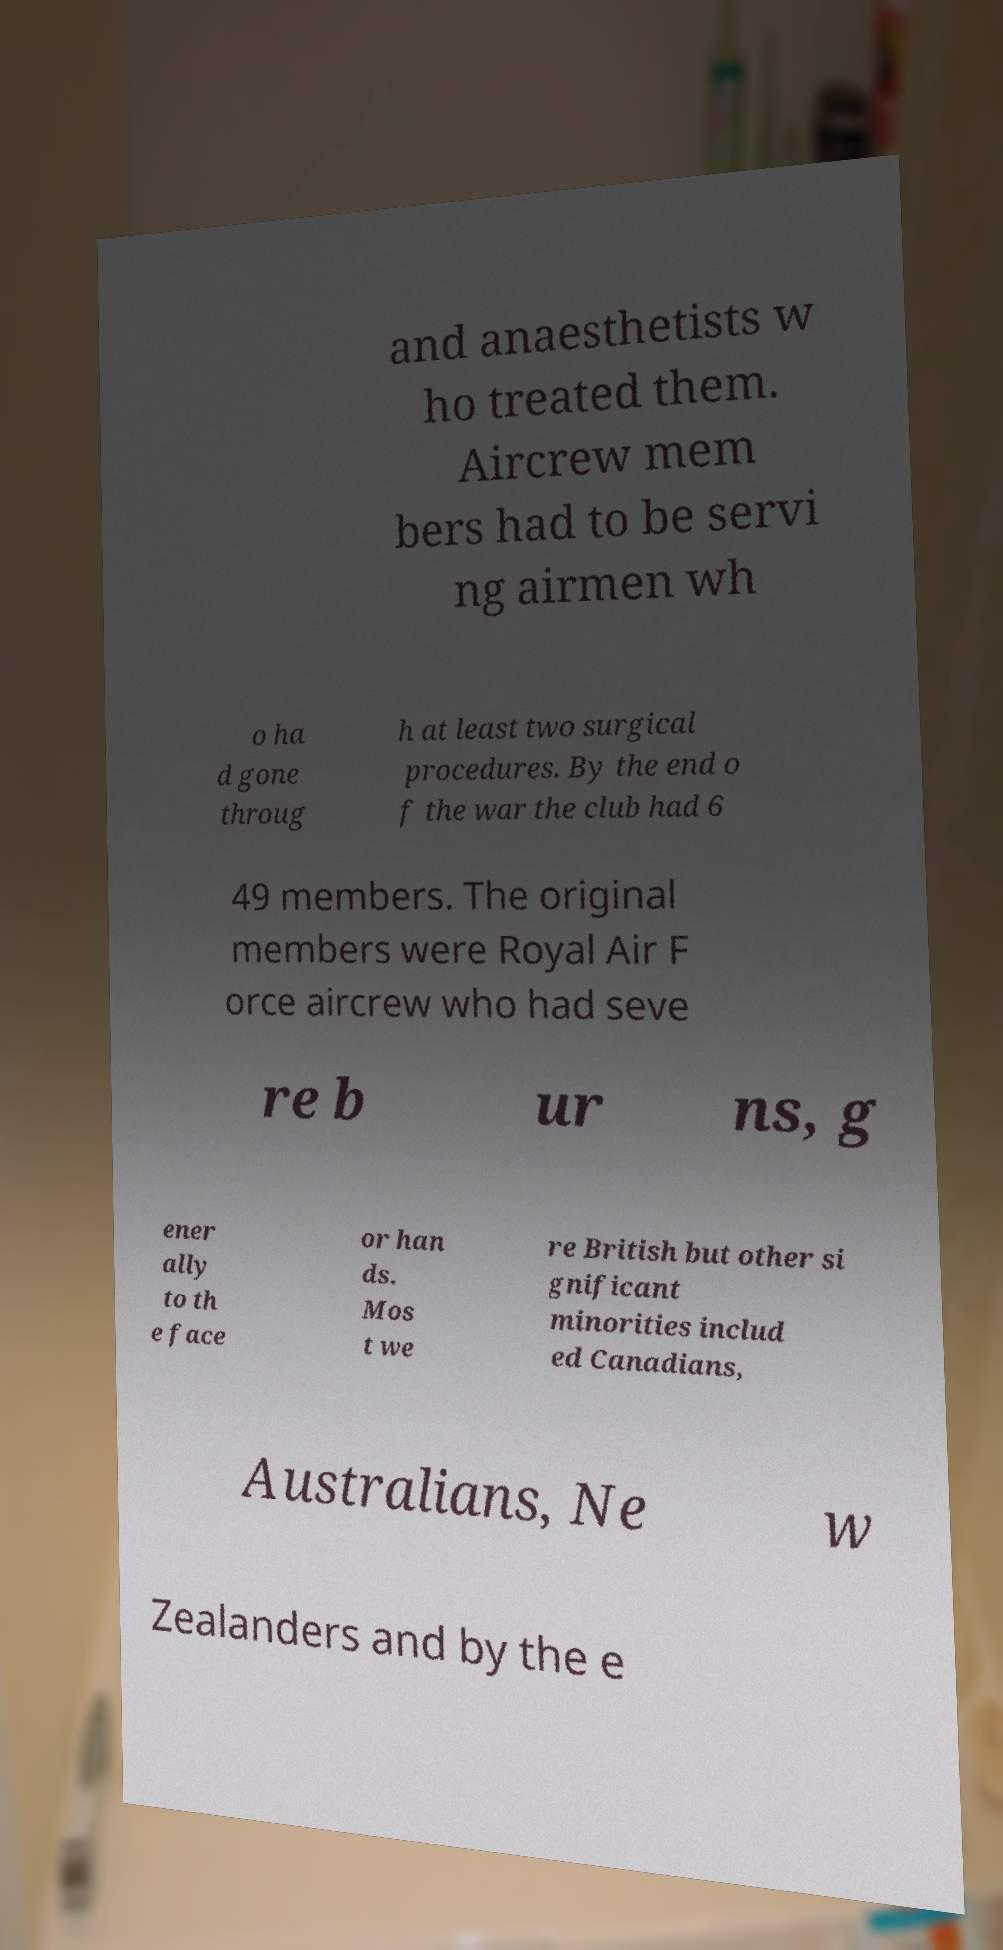Can you read and provide the text displayed in the image?This photo seems to have some interesting text. Can you extract and type it out for me? and anaesthetists w ho treated them. Aircrew mem bers had to be servi ng airmen wh o ha d gone throug h at least two surgical procedures. By the end o f the war the club had 6 49 members. The original members were Royal Air F orce aircrew who had seve re b ur ns, g ener ally to th e face or han ds. Mos t we re British but other si gnificant minorities includ ed Canadians, Australians, Ne w Zealanders and by the e 